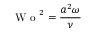Convert formula to latex. <formula><loc_0><loc_0><loc_500><loc_500>W o ^ { 2 } = \frac { a ^ { 2 } \omega } { \nu }</formula> 